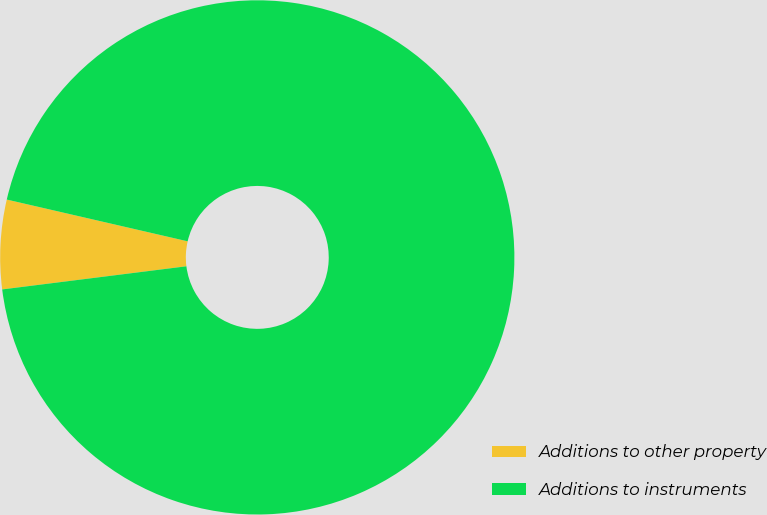Convert chart to OTSL. <chart><loc_0><loc_0><loc_500><loc_500><pie_chart><fcel>Additions to other property<fcel>Additions to instruments<nl><fcel>5.6%<fcel>94.4%<nl></chart> 